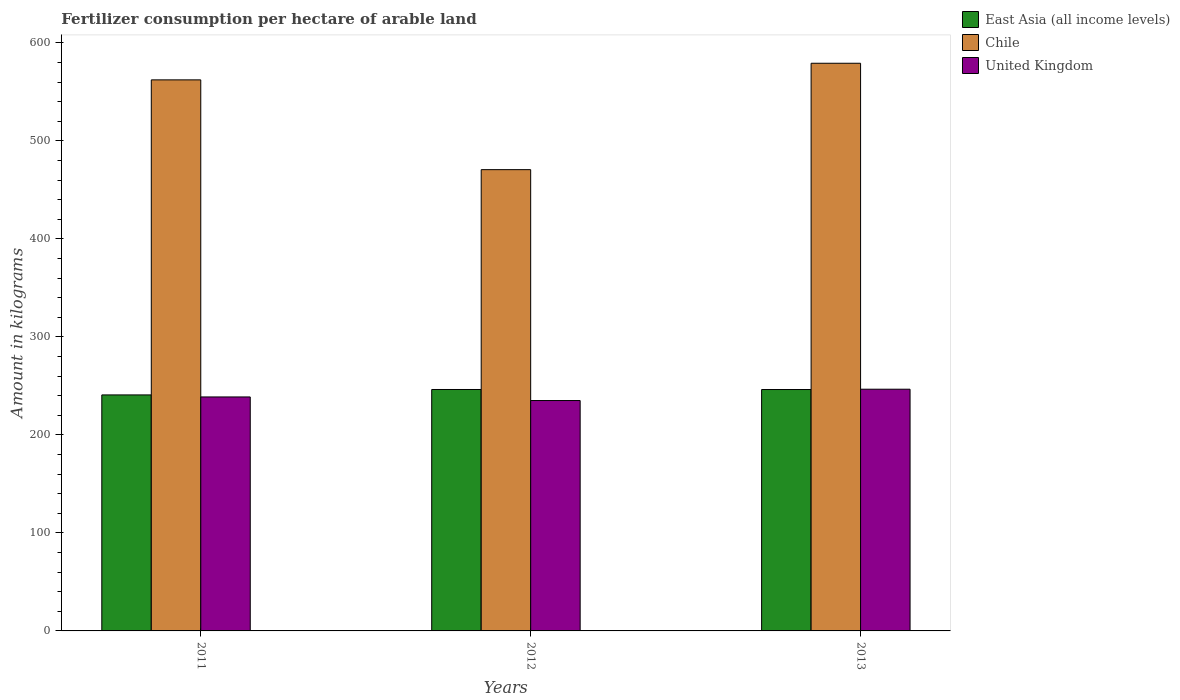How many bars are there on the 3rd tick from the left?
Your answer should be compact. 3. What is the label of the 2nd group of bars from the left?
Provide a succinct answer. 2012. In how many cases, is the number of bars for a given year not equal to the number of legend labels?
Your answer should be very brief. 0. What is the amount of fertilizer consumption in Chile in 2013?
Offer a very short reply. 579.13. Across all years, what is the maximum amount of fertilizer consumption in Chile?
Offer a very short reply. 579.13. Across all years, what is the minimum amount of fertilizer consumption in Chile?
Ensure brevity in your answer.  470.59. In which year was the amount of fertilizer consumption in Chile minimum?
Provide a short and direct response. 2012. What is the total amount of fertilizer consumption in East Asia (all income levels) in the graph?
Your answer should be compact. 733.34. What is the difference between the amount of fertilizer consumption in Chile in 2012 and that in 2013?
Offer a terse response. -108.54. What is the difference between the amount of fertilizer consumption in United Kingdom in 2011 and the amount of fertilizer consumption in Chile in 2012?
Your answer should be compact. -231.89. What is the average amount of fertilizer consumption in East Asia (all income levels) per year?
Your answer should be compact. 244.45. In the year 2011, what is the difference between the amount of fertilizer consumption in United Kingdom and amount of fertilizer consumption in East Asia (all income levels)?
Offer a terse response. -2.07. In how many years, is the amount of fertilizer consumption in East Asia (all income levels) greater than 260 kg?
Provide a short and direct response. 0. What is the ratio of the amount of fertilizer consumption in United Kingdom in 2011 to that in 2012?
Keep it short and to the point. 1.02. Is the difference between the amount of fertilizer consumption in United Kingdom in 2011 and 2012 greater than the difference between the amount of fertilizer consumption in East Asia (all income levels) in 2011 and 2012?
Give a very brief answer. Yes. What is the difference between the highest and the second highest amount of fertilizer consumption in East Asia (all income levels)?
Offer a terse response. 0.04. What is the difference between the highest and the lowest amount of fertilizer consumption in East Asia (all income levels)?
Your response must be concise. 5.54. In how many years, is the amount of fertilizer consumption in East Asia (all income levels) greater than the average amount of fertilizer consumption in East Asia (all income levels) taken over all years?
Offer a very short reply. 2. Are all the bars in the graph horizontal?
Offer a very short reply. No. What is the difference between two consecutive major ticks on the Y-axis?
Make the answer very short. 100. Where does the legend appear in the graph?
Offer a terse response. Top right. How many legend labels are there?
Ensure brevity in your answer.  3. How are the legend labels stacked?
Your response must be concise. Vertical. What is the title of the graph?
Keep it short and to the point. Fertilizer consumption per hectare of arable land. What is the label or title of the Y-axis?
Make the answer very short. Amount in kilograms. What is the Amount in kilograms of East Asia (all income levels) in 2011?
Offer a terse response. 240.77. What is the Amount in kilograms in Chile in 2011?
Your response must be concise. 562.19. What is the Amount in kilograms in United Kingdom in 2011?
Your answer should be compact. 238.7. What is the Amount in kilograms in East Asia (all income levels) in 2012?
Give a very brief answer. 246.31. What is the Amount in kilograms in Chile in 2012?
Offer a terse response. 470.59. What is the Amount in kilograms in United Kingdom in 2012?
Ensure brevity in your answer.  235.03. What is the Amount in kilograms in East Asia (all income levels) in 2013?
Offer a very short reply. 246.27. What is the Amount in kilograms in Chile in 2013?
Offer a very short reply. 579.13. What is the Amount in kilograms in United Kingdom in 2013?
Make the answer very short. 246.59. Across all years, what is the maximum Amount in kilograms of East Asia (all income levels)?
Make the answer very short. 246.31. Across all years, what is the maximum Amount in kilograms of Chile?
Give a very brief answer. 579.13. Across all years, what is the maximum Amount in kilograms of United Kingdom?
Make the answer very short. 246.59. Across all years, what is the minimum Amount in kilograms in East Asia (all income levels)?
Offer a terse response. 240.77. Across all years, what is the minimum Amount in kilograms of Chile?
Keep it short and to the point. 470.59. Across all years, what is the minimum Amount in kilograms in United Kingdom?
Your answer should be compact. 235.03. What is the total Amount in kilograms of East Asia (all income levels) in the graph?
Your answer should be compact. 733.34. What is the total Amount in kilograms of Chile in the graph?
Make the answer very short. 1611.91. What is the total Amount in kilograms in United Kingdom in the graph?
Your response must be concise. 720.32. What is the difference between the Amount in kilograms in East Asia (all income levels) in 2011 and that in 2012?
Provide a short and direct response. -5.54. What is the difference between the Amount in kilograms of Chile in 2011 and that in 2012?
Provide a short and direct response. 91.6. What is the difference between the Amount in kilograms in United Kingdom in 2011 and that in 2012?
Your answer should be very brief. 3.67. What is the difference between the Amount in kilograms in East Asia (all income levels) in 2011 and that in 2013?
Make the answer very short. -5.5. What is the difference between the Amount in kilograms in Chile in 2011 and that in 2013?
Your answer should be compact. -16.94. What is the difference between the Amount in kilograms in United Kingdom in 2011 and that in 2013?
Provide a short and direct response. -7.89. What is the difference between the Amount in kilograms in East Asia (all income levels) in 2012 and that in 2013?
Your answer should be very brief. 0.04. What is the difference between the Amount in kilograms of Chile in 2012 and that in 2013?
Provide a short and direct response. -108.54. What is the difference between the Amount in kilograms in United Kingdom in 2012 and that in 2013?
Make the answer very short. -11.56. What is the difference between the Amount in kilograms in East Asia (all income levels) in 2011 and the Amount in kilograms in Chile in 2012?
Your answer should be compact. -229.82. What is the difference between the Amount in kilograms of East Asia (all income levels) in 2011 and the Amount in kilograms of United Kingdom in 2012?
Provide a short and direct response. 5.74. What is the difference between the Amount in kilograms in Chile in 2011 and the Amount in kilograms in United Kingdom in 2012?
Your response must be concise. 327.16. What is the difference between the Amount in kilograms of East Asia (all income levels) in 2011 and the Amount in kilograms of Chile in 2013?
Offer a very short reply. -338.36. What is the difference between the Amount in kilograms in East Asia (all income levels) in 2011 and the Amount in kilograms in United Kingdom in 2013?
Your response must be concise. -5.82. What is the difference between the Amount in kilograms of Chile in 2011 and the Amount in kilograms of United Kingdom in 2013?
Your answer should be compact. 315.6. What is the difference between the Amount in kilograms in East Asia (all income levels) in 2012 and the Amount in kilograms in Chile in 2013?
Give a very brief answer. -332.82. What is the difference between the Amount in kilograms in East Asia (all income levels) in 2012 and the Amount in kilograms in United Kingdom in 2013?
Provide a succinct answer. -0.29. What is the difference between the Amount in kilograms of Chile in 2012 and the Amount in kilograms of United Kingdom in 2013?
Your response must be concise. 223.99. What is the average Amount in kilograms of East Asia (all income levels) per year?
Provide a succinct answer. 244.45. What is the average Amount in kilograms of Chile per year?
Provide a succinct answer. 537.3. What is the average Amount in kilograms in United Kingdom per year?
Offer a very short reply. 240.11. In the year 2011, what is the difference between the Amount in kilograms in East Asia (all income levels) and Amount in kilograms in Chile?
Give a very brief answer. -321.42. In the year 2011, what is the difference between the Amount in kilograms of East Asia (all income levels) and Amount in kilograms of United Kingdom?
Your response must be concise. 2.07. In the year 2011, what is the difference between the Amount in kilograms of Chile and Amount in kilograms of United Kingdom?
Provide a short and direct response. 323.49. In the year 2012, what is the difference between the Amount in kilograms in East Asia (all income levels) and Amount in kilograms in Chile?
Your response must be concise. -224.28. In the year 2012, what is the difference between the Amount in kilograms in East Asia (all income levels) and Amount in kilograms in United Kingdom?
Ensure brevity in your answer.  11.28. In the year 2012, what is the difference between the Amount in kilograms in Chile and Amount in kilograms in United Kingdom?
Provide a short and direct response. 235.56. In the year 2013, what is the difference between the Amount in kilograms of East Asia (all income levels) and Amount in kilograms of Chile?
Keep it short and to the point. -332.86. In the year 2013, what is the difference between the Amount in kilograms in East Asia (all income levels) and Amount in kilograms in United Kingdom?
Offer a terse response. -0.32. In the year 2013, what is the difference between the Amount in kilograms of Chile and Amount in kilograms of United Kingdom?
Make the answer very short. 332.54. What is the ratio of the Amount in kilograms of East Asia (all income levels) in 2011 to that in 2012?
Your answer should be compact. 0.98. What is the ratio of the Amount in kilograms of Chile in 2011 to that in 2012?
Make the answer very short. 1.19. What is the ratio of the Amount in kilograms of United Kingdom in 2011 to that in 2012?
Ensure brevity in your answer.  1.02. What is the ratio of the Amount in kilograms in East Asia (all income levels) in 2011 to that in 2013?
Provide a short and direct response. 0.98. What is the ratio of the Amount in kilograms of Chile in 2011 to that in 2013?
Your answer should be compact. 0.97. What is the ratio of the Amount in kilograms in Chile in 2012 to that in 2013?
Keep it short and to the point. 0.81. What is the ratio of the Amount in kilograms in United Kingdom in 2012 to that in 2013?
Ensure brevity in your answer.  0.95. What is the difference between the highest and the second highest Amount in kilograms in East Asia (all income levels)?
Your answer should be compact. 0.04. What is the difference between the highest and the second highest Amount in kilograms of Chile?
Your answer should be compact. 16.94. What is the difference between the highest and the second highest Amount in kilograms of United Kingdom?
Ensure brevity in your answer.  7.89. What is the difference between the highest and the lowest Amount in kilograms of East Asia (all income levels)?
Keep it short and to the point. 5.54. What is the difference between the highest and the lowest Amount in kilograms of Chile?
Ensure brevity in your answer.  108.54. What is the difference between the highest and the lowest Amount in kilograms in United Kingdom?
Offer a terse response. 11.56. 